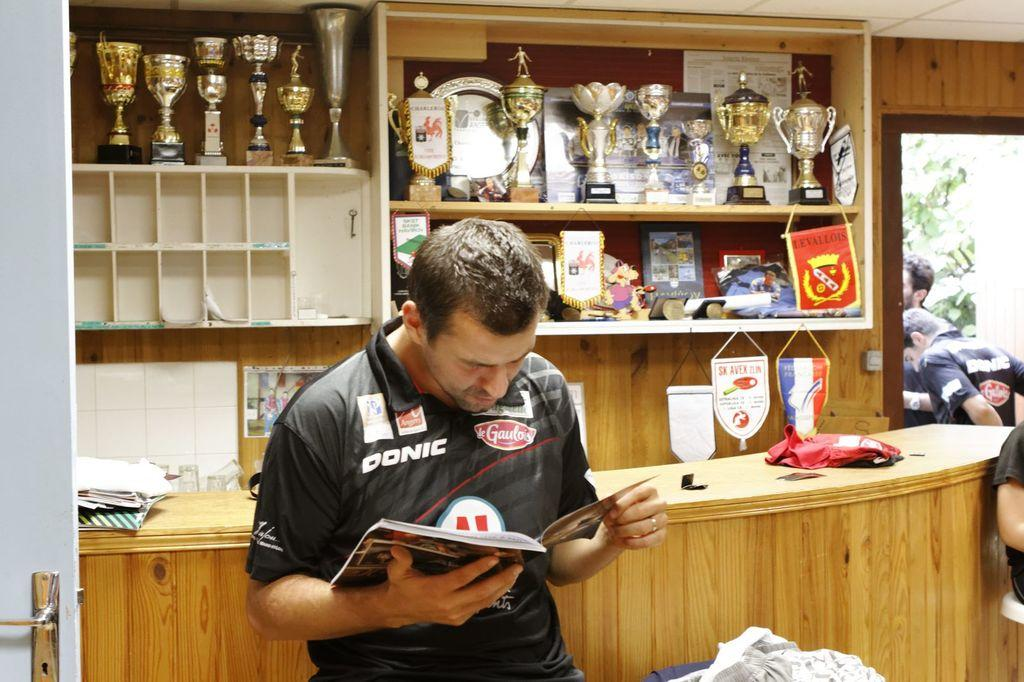<image>
Provide a brief description of the given image. a man wearing a black donic jersey reading a book infront of a bartop 